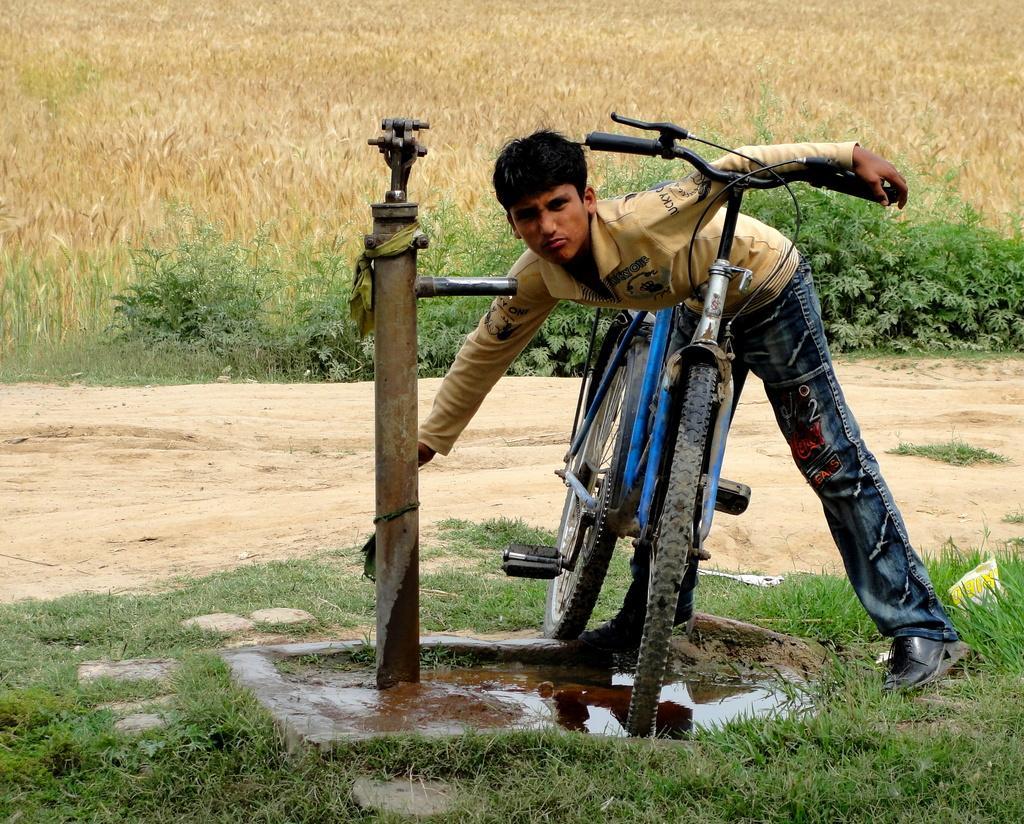Please provide a concise description of this image. In this image I can see a person standing, a bicycle which is blue in color and a metal pipe. I can see some water and some grass on the ground. In the background I can see few plants which are green and brown in color. 